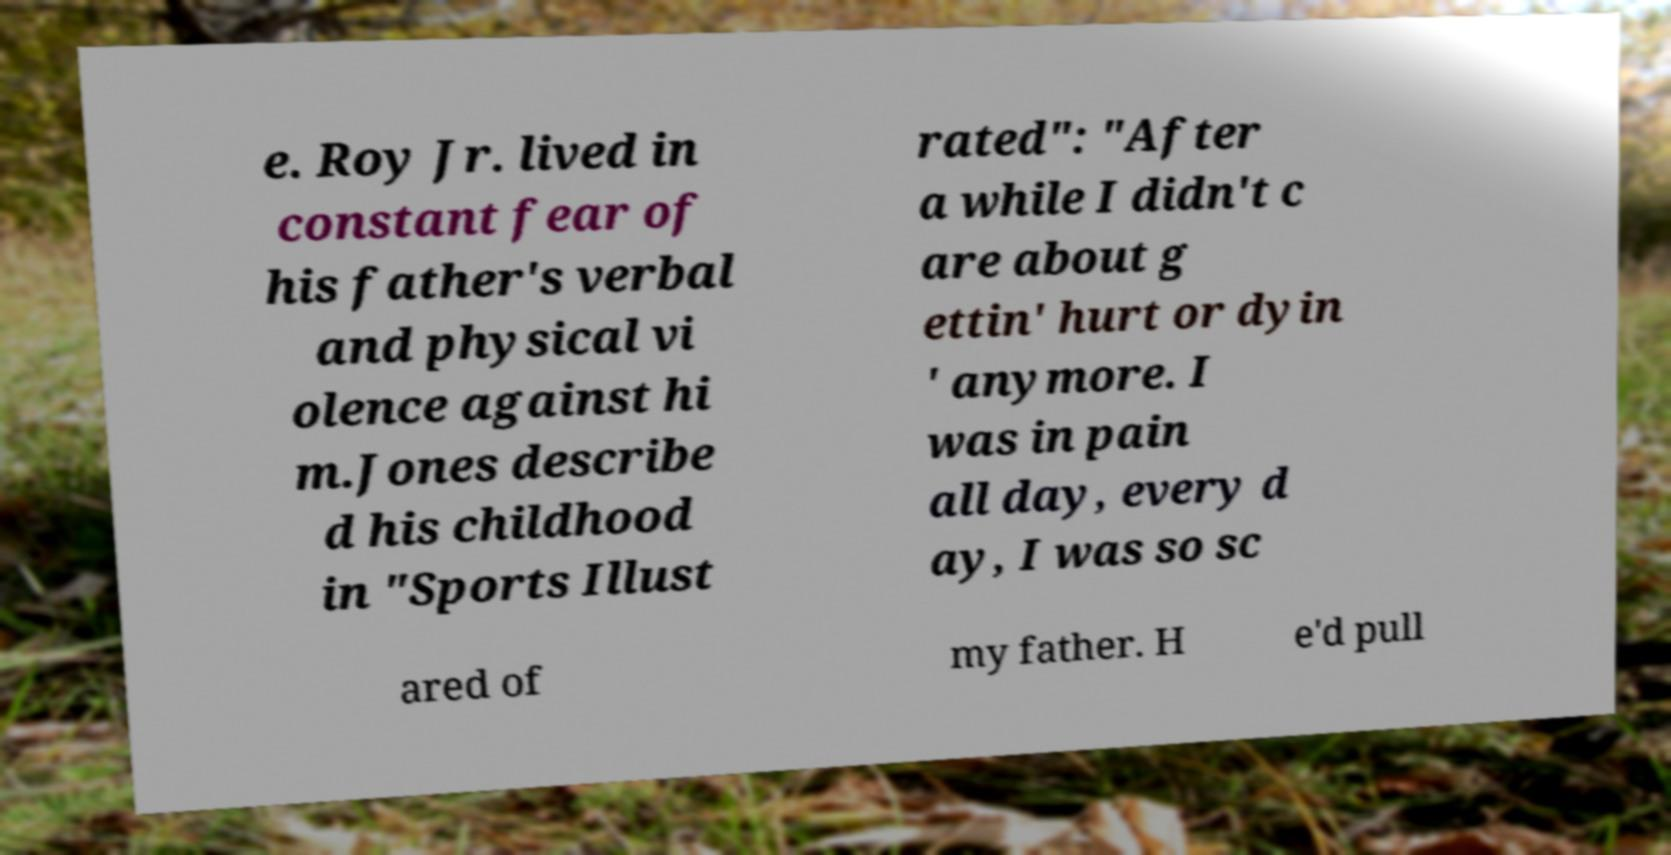I need the written content from this picture converted into text. Can you do that? e. Roy Jr. lived in constant fear of his father's verbal and physical vi olence against hi m.Jones describe d his childhood in "Sports Illust rated": "After a while I didn't c are about g ettin' hurt or dyin ' anymore. I was in pain all day, every d ay, I was so sc ared of my father. H e'd pull 